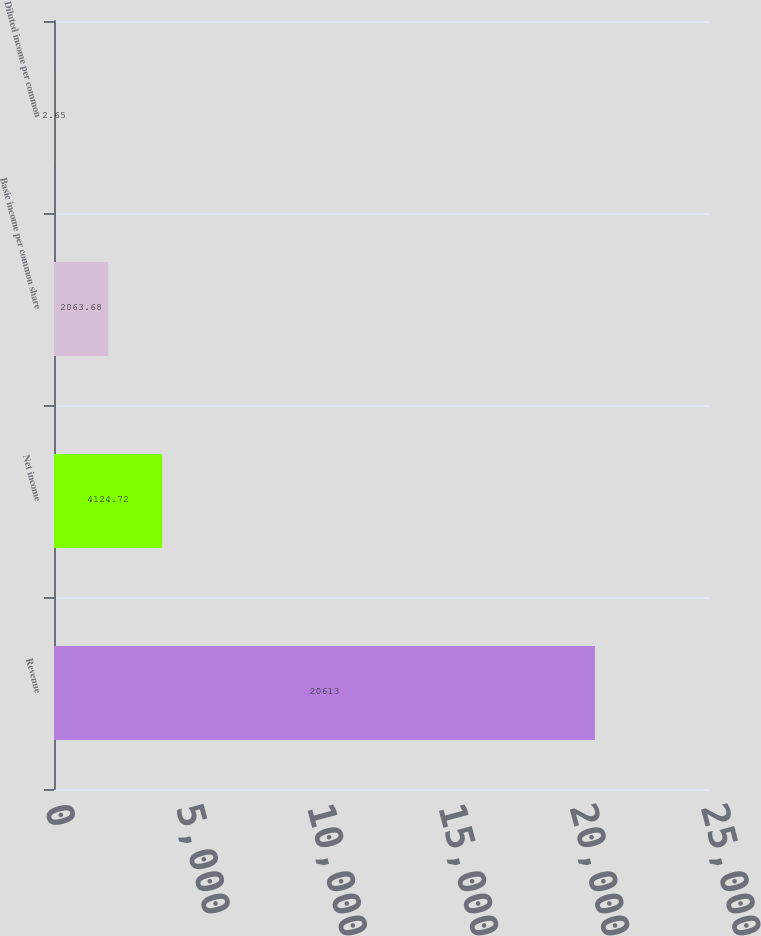Convert chart to OTSL. <chart><loc_0><loc_0><loc_500><loc_500><bar_chart><fcel>Revenue<fcel>Net income<fcel>Basic income per common share<fcel>Diluted income per common<nl><fcel>20613<fcel>4124.72<fcel>2063.68<fcel>2.65<nl></chart> 